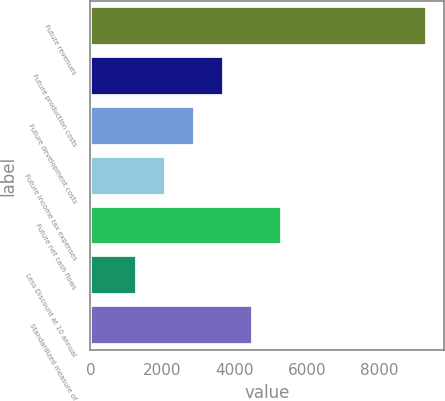<chart> <loc_0><loc_0><loc_500><loc_500><bar_chart><fcel>Future revenues<fcel>Future production costs<fcel>Future development costs<fcel>Future income tax expenses<fcel>Future net cash flows<fcel>Less Discount at 10 annual<fcel>Standardized measure of<nl><fcel>9347<fcel>3711.3<fcel>2906.2<fcel>2101.1<fcel>5321.5<fcel>1296<fcel>4516.4<nl></chart> 